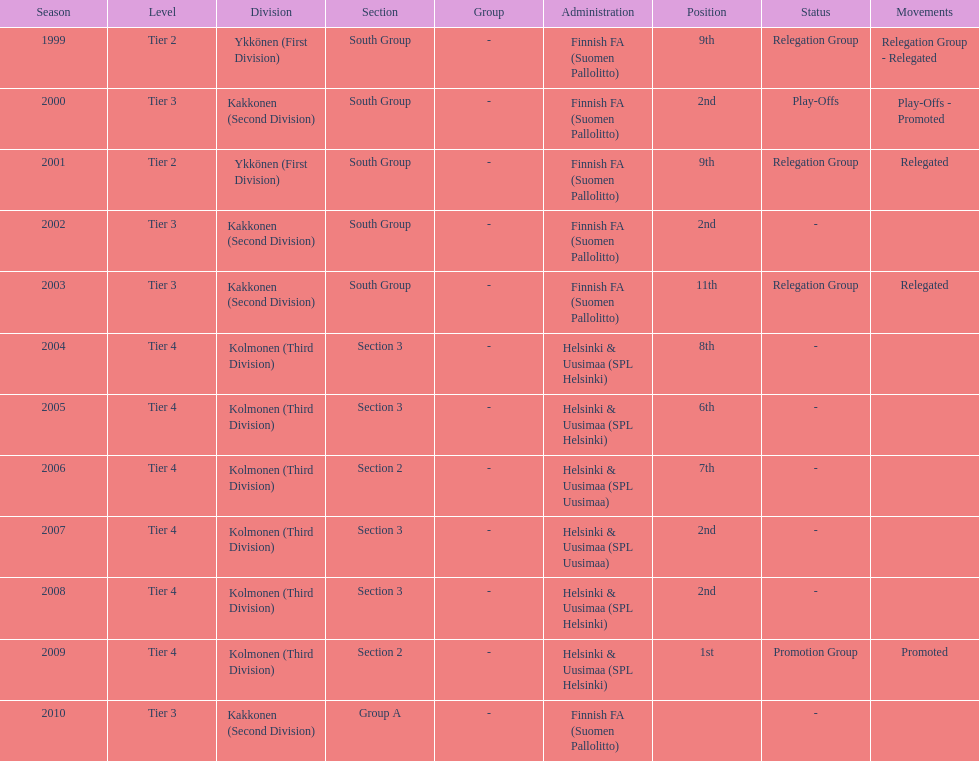How many consecutive times did they play in tier 4? 6. 